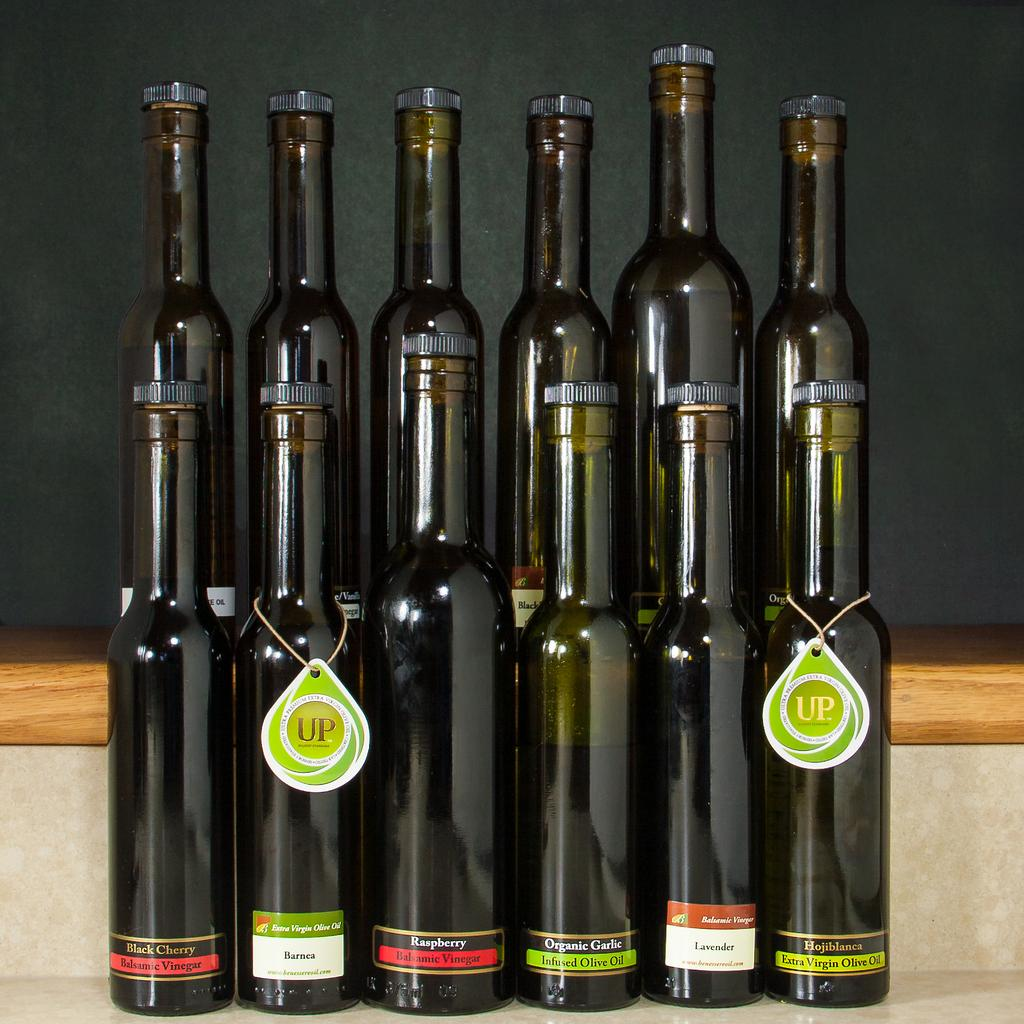<image>
Give a short and clear explanation of the subsequent image. the word UP that is on a bottle 